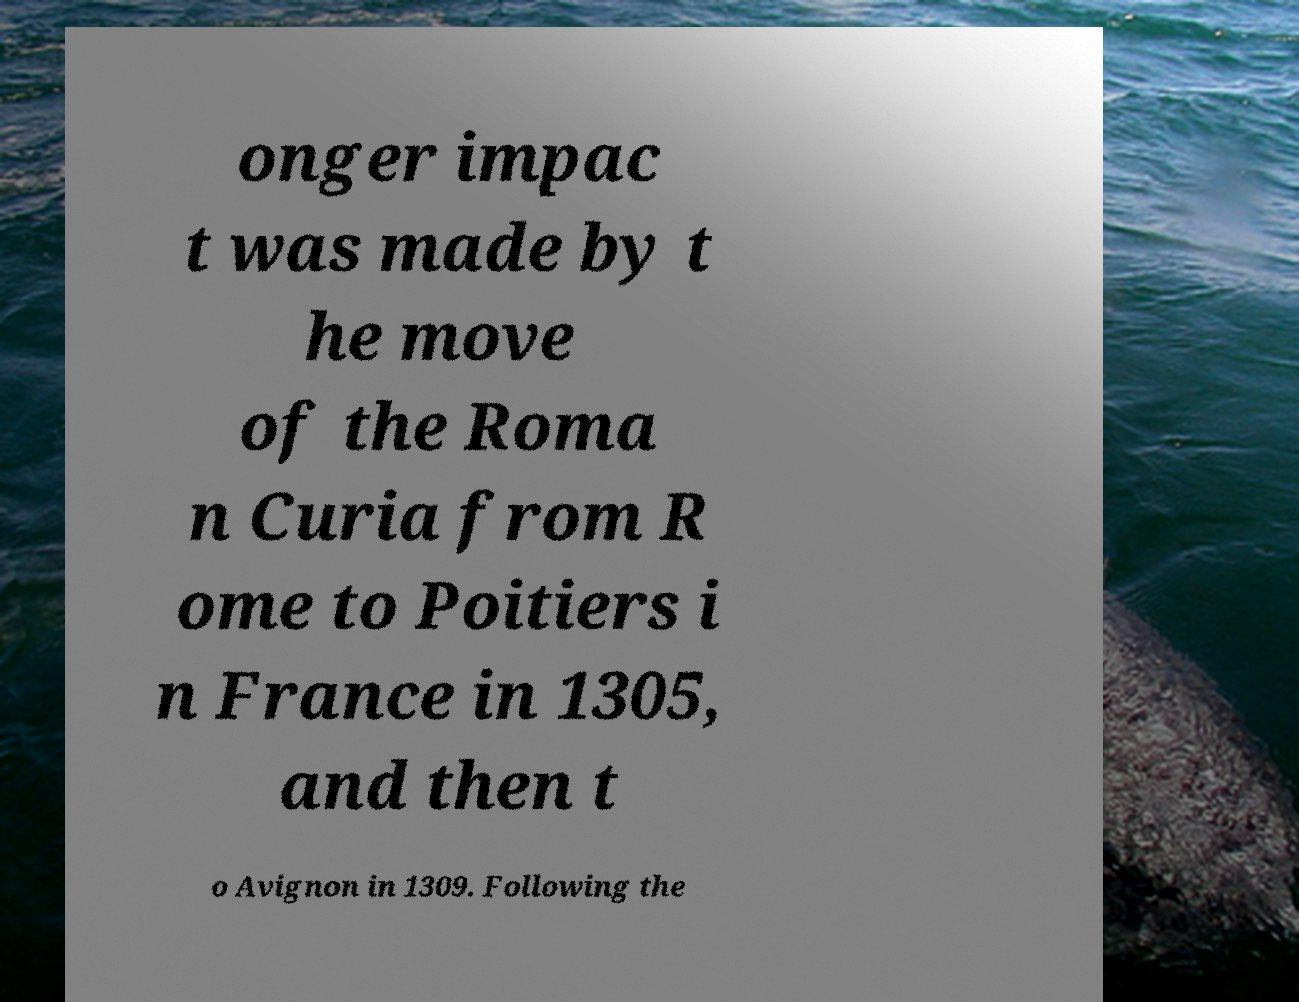Can you read and provide the text displayed in the image?This photo seems to have some interesting text. Can you extract and type it out for me? onger impac t was made by t he move of the Roma n Curia from R ome to Poitiers i n France in 1305, and then t o Avignon in 1309. Following the 